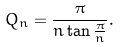<formula> <loc_0><loc_0><loc_500><loc_500>Q _ { n } = { \frac { \pi } { n \tan { \frac { \pi } { n } } } } .</formula> 